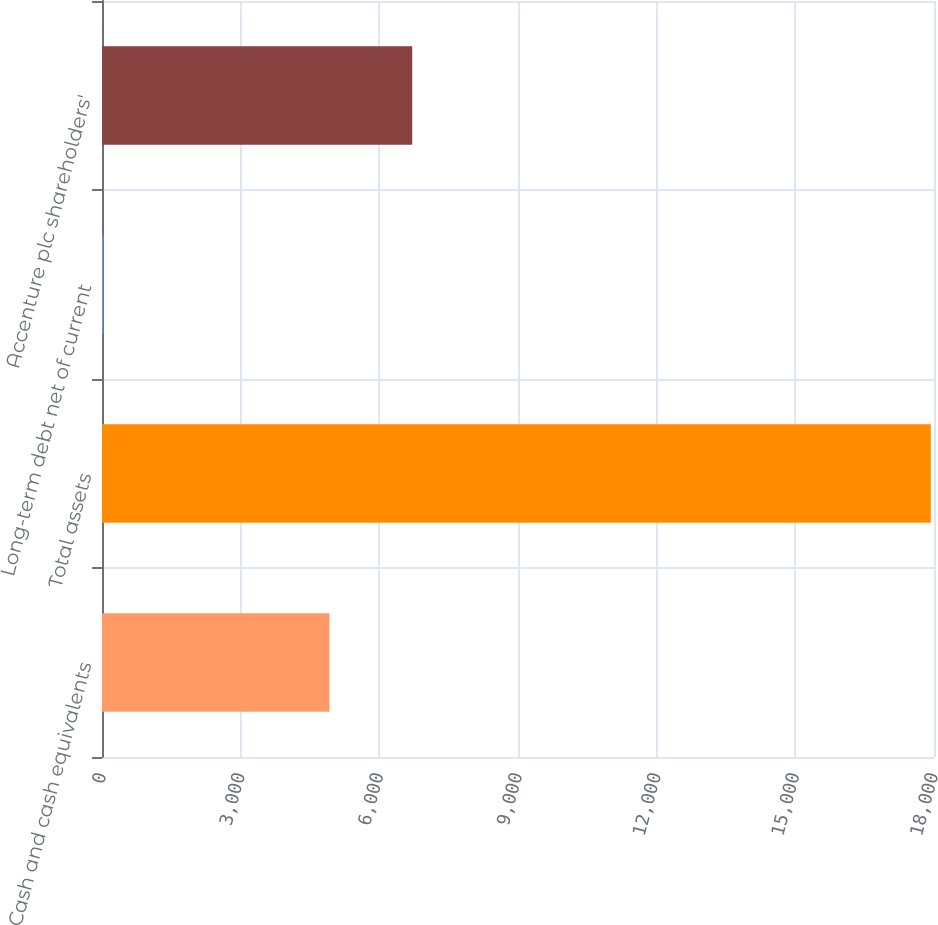<chart> <loc_0><loc_0><loc_500><loc_500><bar_chart><fcel>Cash and cash equivalents<fcel>Total assets<fcel>Long-term debt net of current<fcel>Accenture plc shareholders'<nl><fcel>4921<fcel>17930<fcel>26<fcel>6711.4<nl></chart> 